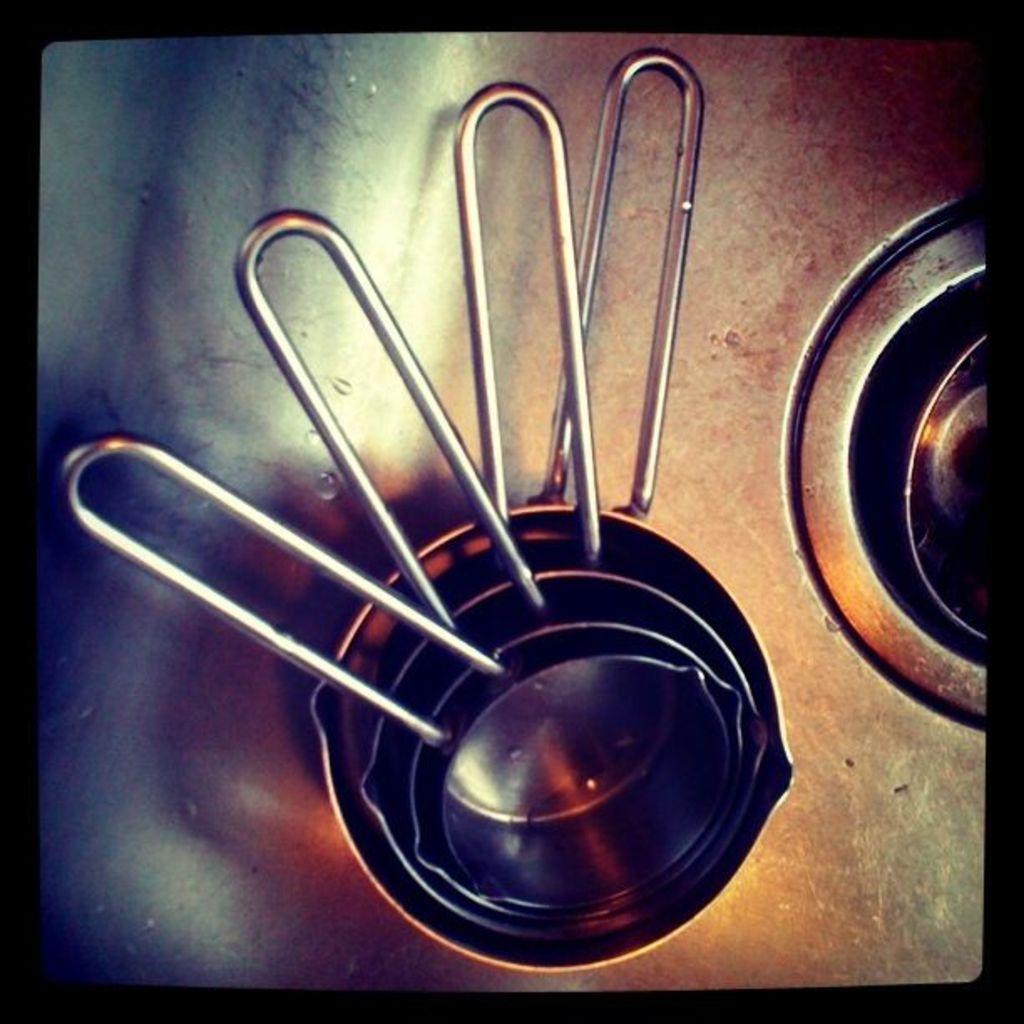Can you describe this image briefly? In this image I can see some vessels which are in silver color. It is on the silver color surface. 